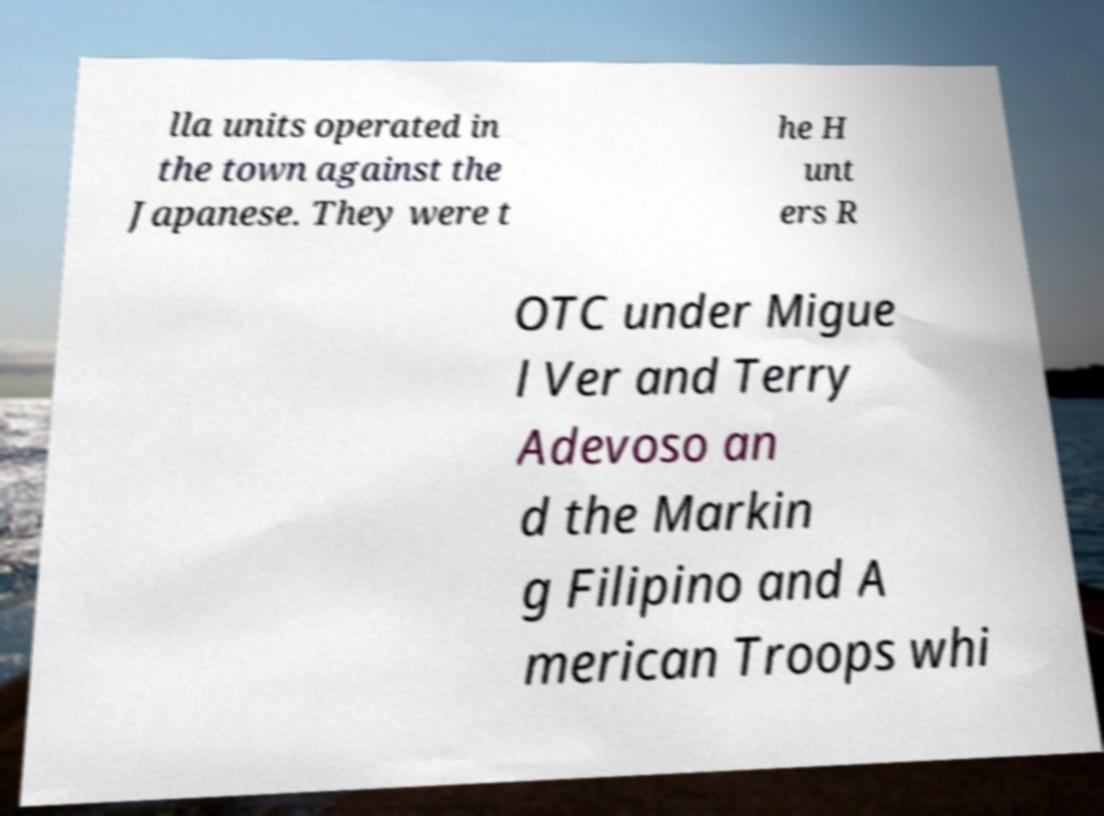Could you extract and type out the text from this image? lla units operated in the town against the Japanese. They were t he H unt ers R OTC under Migue l Ver and Terry Adevoso an d the Markin g Filipino and A merican Troops whi 